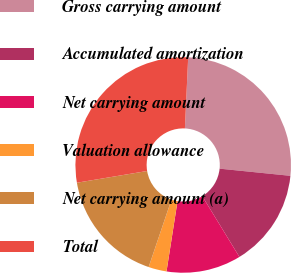Convert chart to OTSL. <chart><loc_0><loc_0><loc_500><loc_500><pie_chart><fcel>Gross carrying amount<fcel>Accumulated amortization<fcel>Net carrying amount<fcel>Valuation allowance<fcel>Net carrying amount (a)<fcel>Total<nl><fcel>25.87%<fcel>14.66%<fcel>11.21%<fcel>2.72%<fcel>17.17%<fcel>28.37%<nl></chart> 